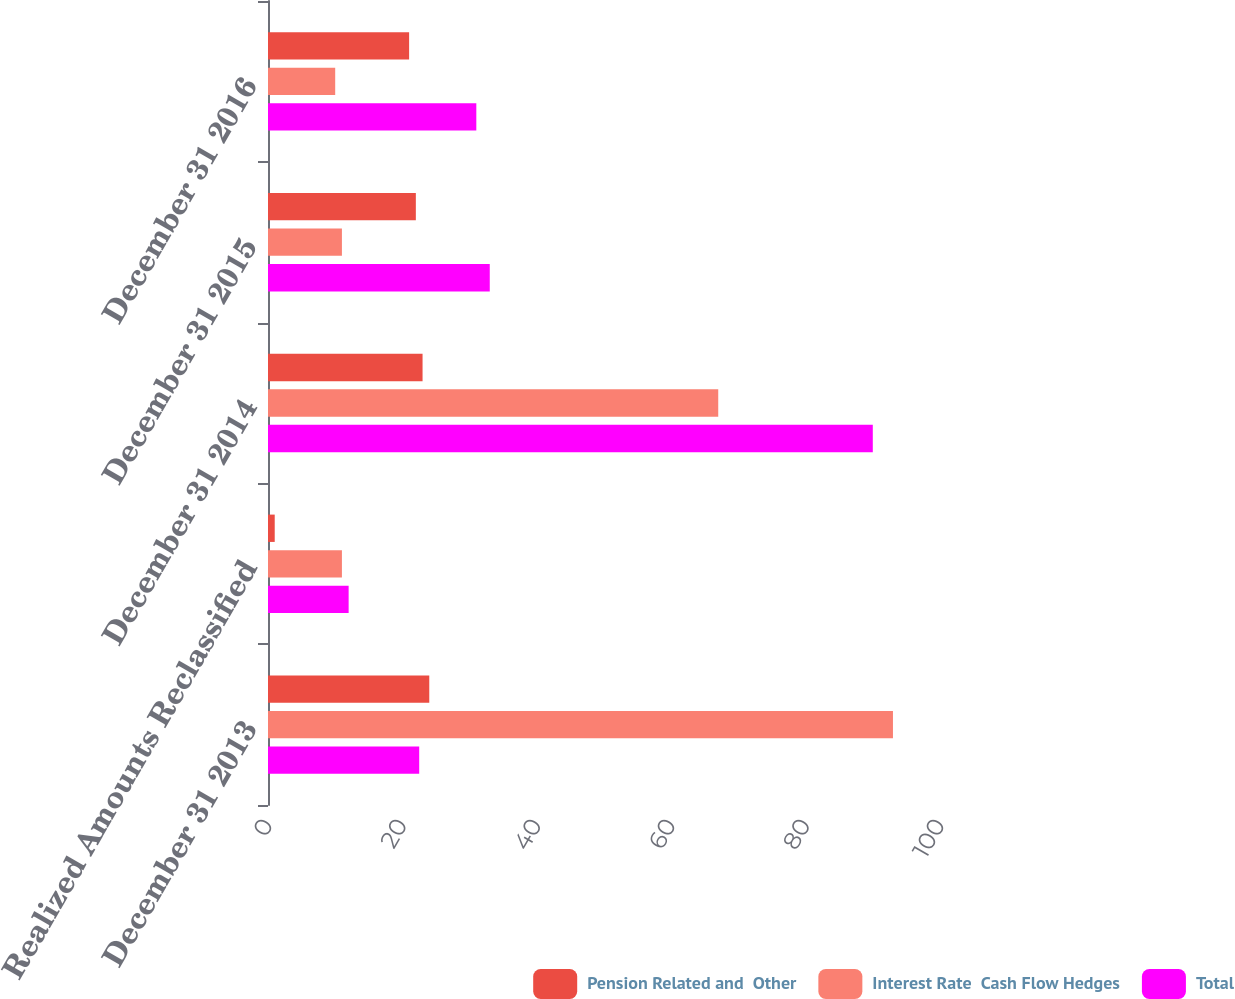Convert chart. <chart><loc_0><loc_0><loc_500><loc_500><stacked_bar_chart><ecel><fcel>December 31 2013<fcel>Realized Amounts Reclassified<fcel>December 31 2014<fcel>December 31 2015<fcel>December 31 2016<nl><fcel>Pension Related and  Other<fcel>24<fcel>1<fcel>23<fcel>22<fcel>21<nl><fcel>Interest Rate  Cash Flow Hedges<fcel>93<fcel>11<fcel>67<fcel>11<fcel>10<nl><fcel>Total<fcel>22.5<fcel>12<fcel>90<fcel>33<fcel>31<nl></chart> 